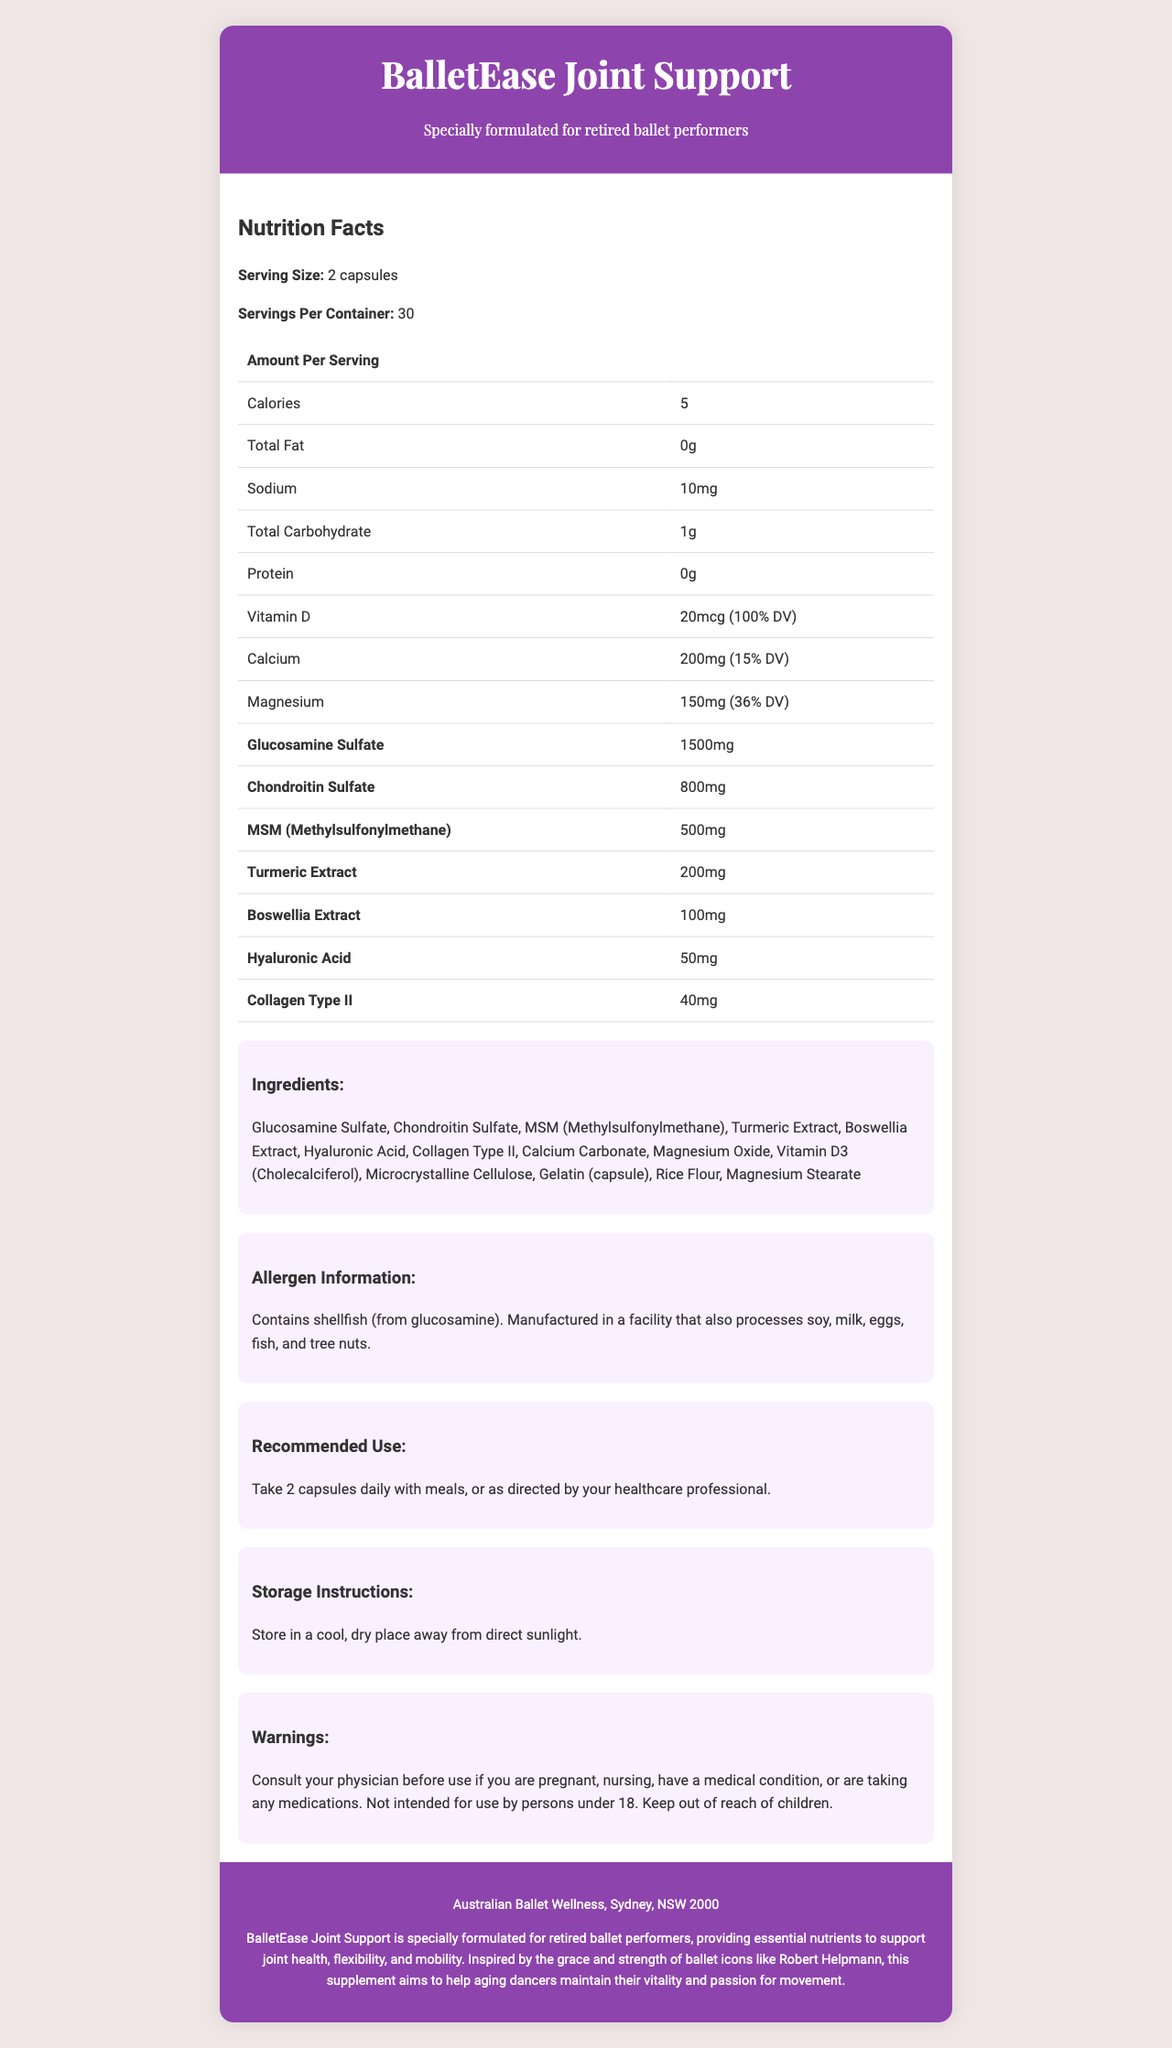what is the serving size for BalletEase Joint Support? The document states that the serving size is 2 capsules.
Answer: 2 capsules how many calories are in one serving of BalletEase Joint Support? The document lists the amount of calories per serving as 5.
Answer: 5 what is the amount of Vitamin D per serving? The document specifies that each serving contains 20 mcg of Vitamin D, which is 100% of the Daily Value (DV).
Answer: 20 mcg (100% DV) how much calcium is in one serving of this supplement? The document indicates that one serving contains 200 mg of calcium, which corresponds to 15% of the Daily Value.
Answer: 200 mg (15% DV) what are the amounts of glucosamine sulfate and chondroitin sulfate per serving? The document states that each serving contains 1500 mg of glucosamine sulfate and 800 mg of chondroitin sulfate.
Answer: 1500 mg and 800 mg which ingredient is present in the smallest amount per serving? The document shows that the amount of Collagen Type II is 40 mg, which is the smallest among the listed ingredients.
Answer: Collagen Type II what allergens does this product contain? The document mentions that the product contains shellfish, derived from glucosamine.
Answer: shellfish (from glucosamine) how should BalletEase Joint Support be stored? The document provides storage instructions stating to store the supplement in a cool, dry place away from direct sunlight.
Answer: in a cool, dry place away from direct sunlight how many servings are in one container of BalletEase Joint Support? The document lists that there are 30 servings per container.
Answer: 30 what is the recommended daily dosage of BalletEase Joint Support? The document recommends taking 2 capsules daily with meals.
Answer: 2 capsules daily with meals where is BalletEase Joint Support manufactured? According to the document, BalletEase Joint Support is manufactured for Australian Ballet Wellness in Sydney, NSW 2000.
Answer: Sydney, NSW 2000 what are the primary benefits of this supplement as described in the document? The document describes that BalletEase Joint Support is formulated to support joint health, flexibility, and mobility, especially for retired ballet performers.
Answer: supports joint health, flexibility, and mobility which of the following is NOT an ingredient in BalletEase Joint Support? A. Glucosamine Sulfate B. Vitamin C C. Turmeric Extract D. Chondroitin Sulfate The document does not list Vitamin C as an ingredient.
Answer: B what is the correct percentage of Daily Value (%DV) for Magnesium per serving? A. 15% B. 20% C. 36% D. 50% The document states that Magnesium constitutes 36% of the Daily Value per serving.
Answer: C is this supplement meant for children under 18? The document specifically mentions that it is not intended for use by persons under 18.
Answer: No summarize the main purpose of BalletEase Joint Support. The document describes that this supplement is specially formulated to provide essential nutrients that help maintain the vitality and passion for movement in aging dancers.
Answer: BalletEase Joint Support is a joint health supplement designed specifically for retired ballet performers to support their joint health, flexibility, and mobility. what is the exact quantity of Boswellia Extract per serving? The document lists that each serving contains 100 mg of Boswellia Extract.
Answer: 100 mg how many capsules should be taken per day according to the recommended use? A. 1 B. 2 C. 3 D. 4 The recommended use states that 2 capsules should be taken daily.
Answer: B can I determine the price of BalletEase Joint Support from this document? The document does not provide any information about the price of the product.
Answer: Not enough information 